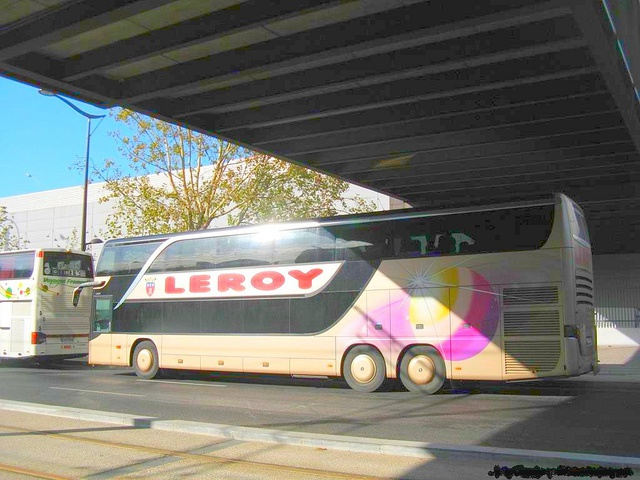Describe the objects in this image and their specific colors. I can see bus in darkgreen, gray, ivory, black, and darkgray tones and bus in darkgreen, ivory, darkgray, and gray tones in this image. 